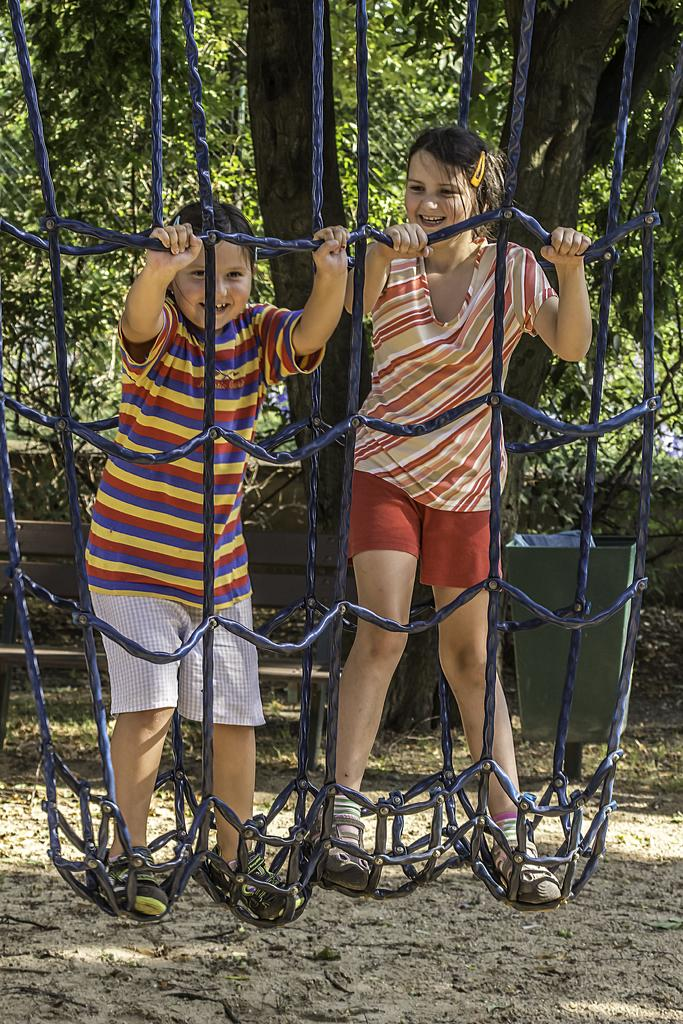Who is present in the image? There are girls in the image. What are the girls doing in the image? The girls are standing and holding ropes. What can be seen in the background of the image? There are trees in the background of the image. What object is on the ground in the image? There is a dustbin on the ground in the image. What year is depicted in the image? The image does not depict a specific year; it is a photograph of girls holding ropes. Can you see a pipe in the image? There is no pipe present in the image. 